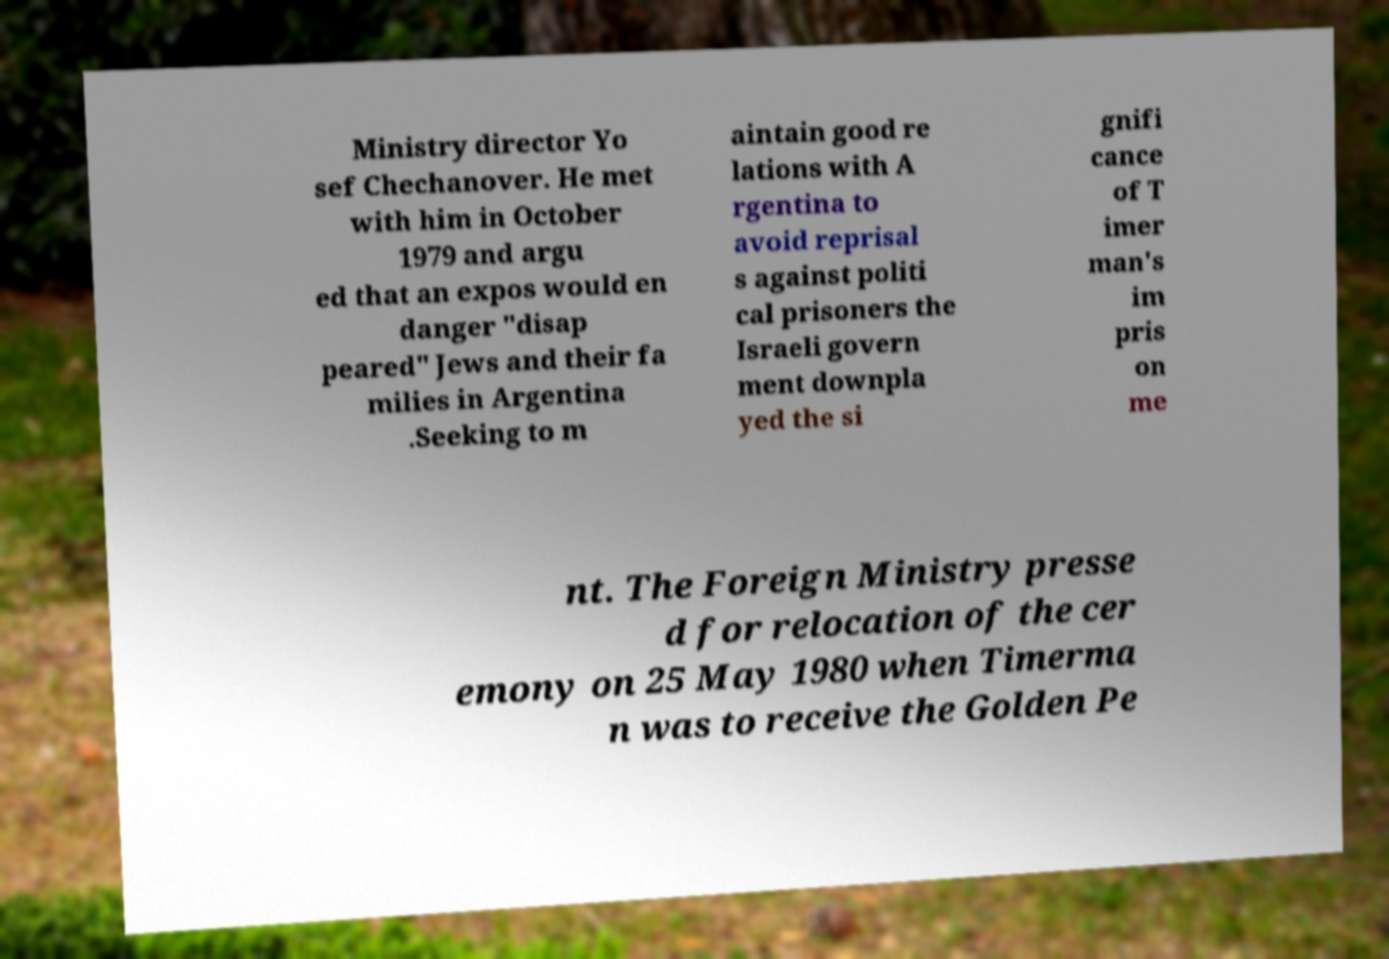For documentation purposes, I need the text within this image transcribed. Could you provide that? Ministry director Yo sef Chechanover. He met with him in October 1979 and argu ed that an expos would en danger "disap peared" Jews and their fa milies in Argentina .Seeking to m aintain good re lations with A rgentina to avoid reprisal s against politi cal prisoners the Israeli govern ment downpla yed the si gnifi cance of T imer man's im pris on me nt. The Foreign Ministry presse d for relocation of the cer emony on 25 May 1980 when Timerma n was to receive the Golden Pe 